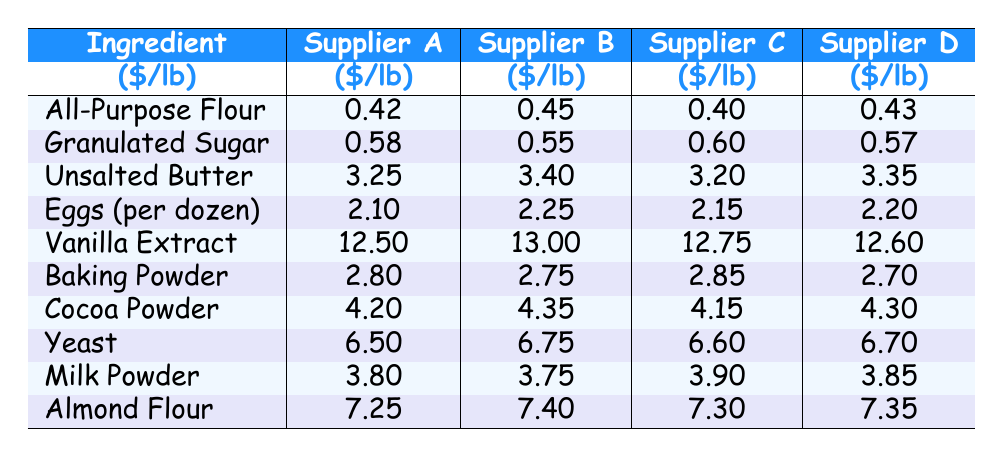What is the cheapest supplier for All-Purpose Flour? From the table, we can see the prices for All-Purpose Flour are 0.42 for Supplier A, 0.45 for Supplier B, 0.40 for Supplier C, and 0.43 for Supplier D. Supplier C has the lowest price at 0.40.
Answer: Supplier C What is the price difference between the most expensive and cheapest Vanilla Extract? The prices for Vanilla Extract are 12.50 for Supplier A and 12.60 for Supplier D. The difference is calculated as 12.60 - 12.50 = 0.10.
Answer: 0.10 Which supplier offers the lowest price for Unsalted Butter? The prices for Unsalted Butter from the suppliers are 3.25, 3.40, 3.20, and 3.35, respectively. Supplier C has the lowest price at 3.20.
Answer: Supplier C What is the average cost of Cocoa Powder from all suppliers? To find the average, first sum the costs: 4.20 + 4.35 + 4.15 + 4.30 = 17.00. Then, divide by 4 (the number of suppliers): 17.00 / 4 = 4.25.
Answer: 4.25 Which ingredient has the highest price per pound from Supplier B? Looking at Supplier B's prices, we see: 0.45 (All-Purpose Flour), 0.55 (Granulated Sugar), 3.40 (Unsalted Butter), 2.25 (Eggs), 13.00 (Vanilla Extract), 2.75 (Baking Powder), 4.35 (Cocoa Powder), 6.75 (Yeast), 3.75 (Milk Powder), and 7.40 (Almond Flour). The highest is 13.00 for Vanilla Extract.
Answer: Vanilla Extract Is there any supplier that offers cheaper Granulated Sugar than 0.60? Checking the prices, we find Supplier A at 0.58 and Supplier B at 0.55, which are both less than 0.60. Thus, the answer is yes.
Answer: Yes What is the total cost of buying one pound of each ingredient from Supplier D? The prices from Supplier D are 0.43, 0.57, 3.35, 2.20, 12.60, 2.70, 4.30, 6.70, 3.85, and 7.35, respectively. Adding these gives: 0.43 + 0.57 + 3.35 + 2.20 + 12.60 + 2.70 + 4.30 + 6.70 + 3.85 + 7.35 = 44.05.
Answer: 44.05 Who is the best supplier for Milk Powder? The prices for Milk Powder are 3.80 (Supplier A), 3.75 (Supplier B), 3.90 (Supplier C), and 3.85 (Supplier D). Supplier B offers the lowest price of 3.75.
Answer: Supplier B What is the combined cost of buying one pound of Baking Powder and two pounds of Cocoa Powder from Supplier C? For Supplier C, Baking Powder costs 2.85, while Cocoa Powder costs 4.15. The total cost is 2.85 + (2 * 4.15) = 2.85 + 8.30 = 11.15.
Answer: 11.15 Is the cost of Yeast from Supplier A greater than the average price of the same ingredient across all suppliers? Supplier A's Yeast price is 6.50. The average price for Yeast from all suppliers is calculated as (6.50 + 6.75 + 6.60 + 6.70) / 4 = 6.64. Since 6.50 is less than 6.64, the answer is no.
Answer: No 